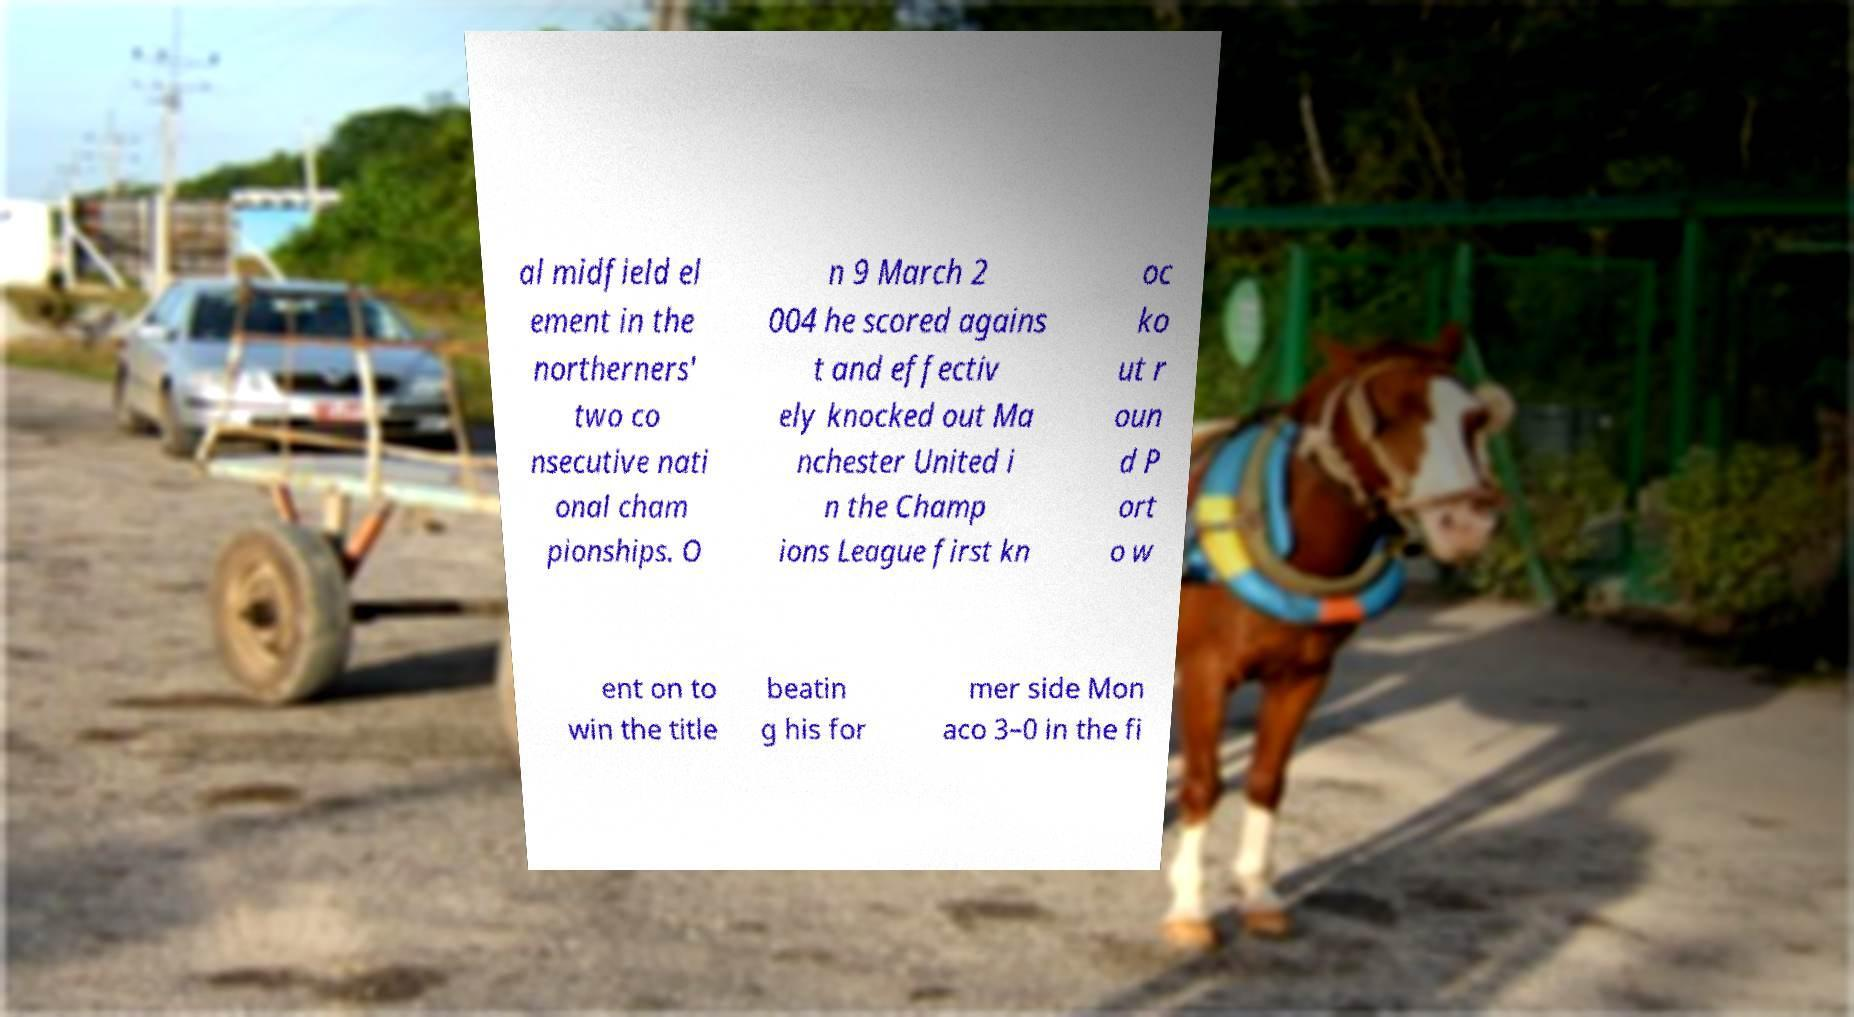What messages or text are displayed in this image? I need them in a readable, typed format. al midfield el ement in the northerners' two co nsecutive nati onal cham pionships. O n 9 March 2 004 he scored agains t and effectiv ely knocked out Ma nchester United i n the Champ ions League first kn oc ko ut r oun d P ort o w ent on to win the title beatin g his for mer side Mon aco 3–0 in the fi 